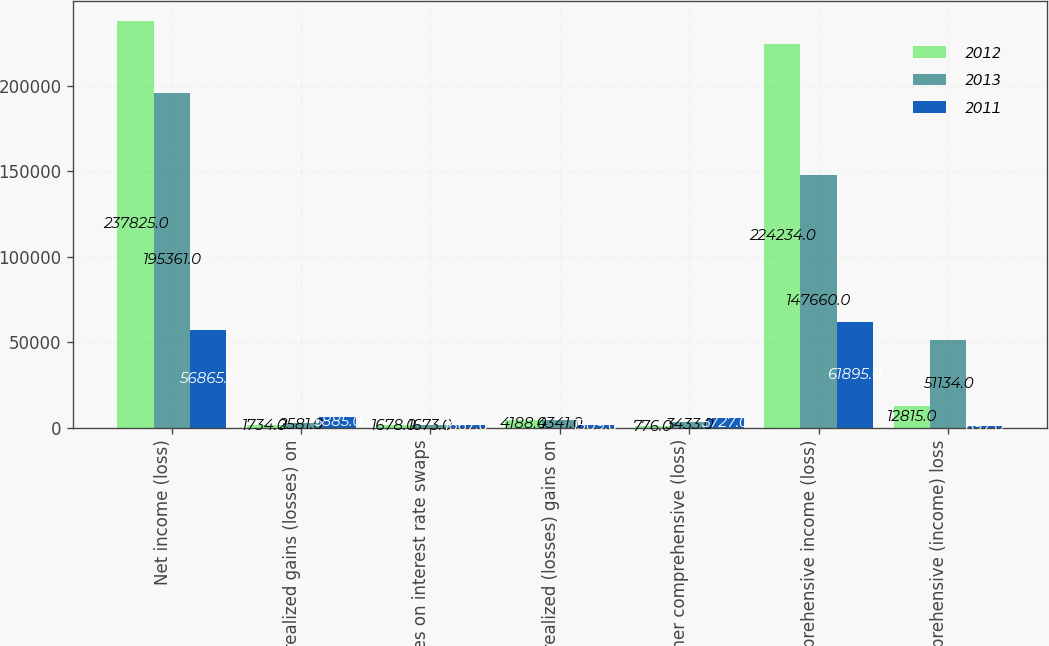Convert chart. <chart><loc_0><loc_0><loc_500><loc_500><stacked_bar_chart><ecel><fcel>Net income (loss)<fcel>Unrealized gains (losses) on<fcel>Losses on interest rate swaps<fcel>Unrealized (losses) gains on<fcel>Other comprehensive (loss)<fcel>Comprehensive income (loss)<fcel>Comprehensive (income) loss<nl><fcel>2012<fcel>237825<fcel>1734<fcel>1678<fcel>4188<fcel>776<fcel>224234<fcel>12815<nl><fcel>2013<fcel>195361<fcel>2581<fcel>1673<fcel>4341<fcel>3433<fcel>147660<fcel>51134<nl><fcel>2011<fcel>56865<fcel>5885<fcel>1667<fcel>1509<fcel>5727<fcel>61895<fcel>697<nl></chart> 